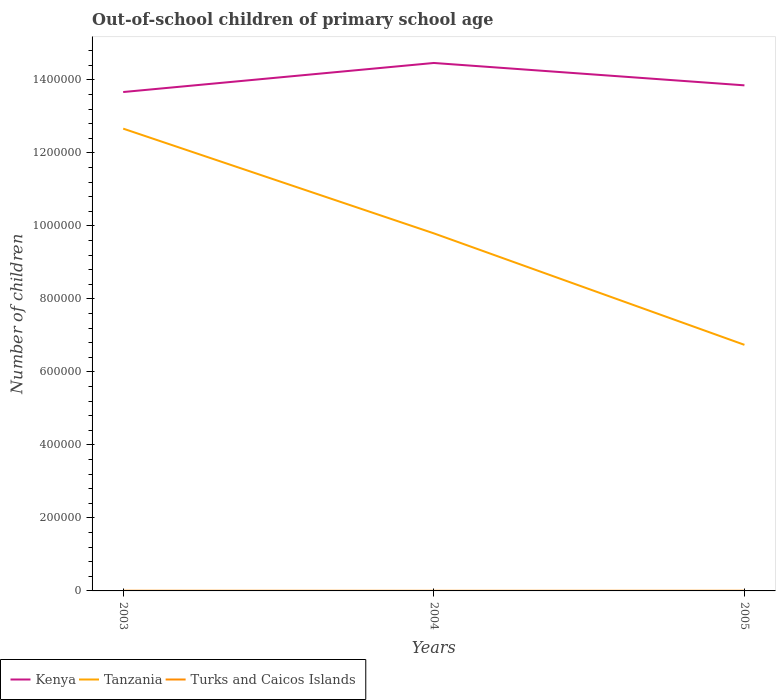How many different coloured lines are there?
Your answer should be compact. 3. Across all years, what is the maximum number of out-of-school children in Kenya?
Your answer should be compact. 1.37e+06. In which year was the number of out-of-school children in Turks and Caicos Islands maximum?
Ensure brevity in your answer.  2004. What is the total number of out-of-school children in Kenya in the graph?
Offer a terse response. -7.96e+04. What is the difference between the highest and the second highest number of out-of-school children in Turks and Caicos Islands?
Offer a terse response. 179. What is the difference between the highest and the lowest number of out-of-school children in Kenya?
Offer a terse response. 1. Is the number of out-of-school children in Turks and Caicos Islands strictly greater than the number of out-of-school children in Kenya over the years?
Make the answer very short. Yes. How many years are there in the graph?
Your answer should be very brief. 3. What is the difference between two consecutive major ticks on the Y-axis?
Your answer should be very brief. 2.00e+05. Does the graph contain grids?
Provide a short and direct response. No. How many legend labels are there?
Offer a very short reply. 3. What is the title of the graph?
Your answer should be very brief. Out-of-school children of primary school age. Does "Zimbabwe" appear as one of the legend labels in the graph?
Your response must be concise. No. What is the label or title of the Y-axis?
Provide a succinct answer. Number of children. What is the Number of children of Kenya in 2003?
Offer a very short reply. 1.37e+06. What is the Number of children of Tanzania in 2003?
Make the answer very short. 1.27e+06. What is the Number of children of Turks and Caicos Islands in 2003?
Your answer should be compact. 532. What is the Number of children in Kenya in 2004?
Provide a short and direct response. 1.45e+06. What is the Number of children of Tanzania in 2004?
Keep it short and to the point. 9.80e+05. What is the Number of children in Turks and Caicos Islands in 2004?
Ensure brevity in your answer.  353. What is the Number of children of Kenya in 2005?
Give a very brief answer. 1.38e+06. What is the Number of children in Tanzania in 2005?
Your answer should be very brief. 6.74e+05. What is the Number of children of Turks and Caicos Islands in 2005?
Your response must be concise. 477. Across all years, what is the maximum Number of children in Kenya?
Keep it short and to the point. 1.45e+06. Across all years, what is the maximum Number of children in Tanzania?
Give a very brief answer. 1.27e+06. Across all years, what is the maximum Number of children of Turks and Caicos Islands?
Your response must be concise. 532. Across all years, what is the minimum Number of children of Kenya?
Offer a very short reply. 1.37e+06. Across all years, what is the minimum Number of children in Tanzania?
Your answer should be compact. 6.74e+05. Across all years, what is the minimum Number of children of Turks and Caicos Islands?
Your answer should be very brief. 353. What is the total Number of children in Kenya in the graph?
Your response must be concise. 4.20e+06. What is the total Number of children in Tanzania in the graph?
Your answer should be compact. 2.92e+06. What is the total Number of children of Turks and Caicos Islands in the graph?
Keep it short and to the point. 1362. What is the difference between the Number of children in Kenya in 2003 and that in 2004?
Keep it short and to the point. -7.96e+04. What is the difference between the Number of children in Tanzania in 2003 and that in 2004?
Offer a terse response. 2.87e+05. What is the difference between the Number of children in Turks and Caicos Islands in 2003 and that in 2004?
Offer a very short reply. 179. What is the difference between the Number of children in Kenya in 2003 and that in 2005?
Give a very brief answer. -1.83e+04. What is the difference between the Number of children in Tanzania in 2003 and that in 2005?
Ensure brevity in your answer.  5.92e+05. What is the difference between the Number of children in Kenya in 2004 and that in 2005?
Your answer should be very brief. 6.13e+04. What is the difference between the Number of children in Tanzania in 2004 and that in 2005?
Your answer should be compact. 3.05e+05. What is the difference between the Number of children in Turks and Caicos Islands in 2004 and that in 2005?
Your answer should be very brief. -124. What is the difference between the Number of children of Kenya in 2003 and the Number of children of Tanzania in 2004?
Your answer should be compact. 3.87e+05. What is the difference between the Number of children in Kenya in 2003 and the Number of children in Turks and Caicos Islands in 2004?
Give a very brief answer. 1.37e+06. What is the difference between the Number of children of Tanzania in 2003 and the Number of children of Turks and Caicos Islands in 2004?
Offer a terse response. 1.27e+06. What is the difference between the Number of children in Kenya in 2003 and the Number of children in Tanzania in 2005?
Ensure brevity in your answer.  6.92e+05. What is the difference between the Number of children of Kenya in 2003 and the Number of children of Turks and Caicos Islands in 2005?
Make the answer very short. 1.37e+06. What is the difference between the Number of children of Tanzania in 2003 and the Number of children of Turks and Caicos Islands in 2005?
Give a very brief answer. 1.27e+06. What is the difference between the Number of children in Kenya in 2004 and the Number of children in Tanzania in 2005?
Your answer should be compact. 7.72e+05. What is the difference between the Number of children in Kenya in 2004 and the Number of children in Turks and Caicos Islands in 2005?
Your answer should be very brief. 1.45e+06. What is the difference between the Number of children of Tanzania in 2004 and the Number of children of Turks and Caicos Islands in 2005?
Offer a very short reply. 9.79e+05. What is the average Number of children in Kenya per year?
Keep it short and to the point. 1.40e+06. What is the average Number of children of Tanzania per year?
Keep it short and to the point. 9.73e+05. What is the average Number of children of Turks and Caicos Islands per year?
Offer a terse response. 454. In the year 2003, what is the difference between the Number of children in Kenya and Number of children in Tanzania?
Keep it short and to the point. 1.00e+05. In the year 2003, what is the difference between the Number of children in Kenya and Number of children in Turks and Caicos Islands?
Make the answer very short. 1.37e+06. In the year 2003, what is the difference between the Number of children of Tanzania and Number of children of Turks and Caicos Islands?
Ensure brevity in your answer.  1.27e+06. In the year 2004, what is the difference between the Number of children of Kenya and Number of children of Tanzania?
Provide a succinct answer. 4.67e+05. In the year 2004, what is the difference between the Number of children in Kenya and Number of children in Turks and Caicos Islands?
Provide a short and direct response. 1.45e+06. In the year 2004, what is the difference between the Number of children in Tanzania and Number of children in Turks and Caicos Islands?
Make the answer very short. 9.79e+05. In the year 2005, what is the difference between the Number of children in Kenya and Number of children in Tanzania?
Your answer should be very brief. 7.11e+05. In the year 2005, what is the difference between the Number of children in Kenya and Number of children in Turks and Caicos Islands?
Give a very brief answer. 1.38e+06. In the year 2005, what is the difference between the Number of children of Tanzania and Number of children of Turks and Caicos Islands?
Offer a terse response. 6.74e+05. What is the ratio of the Number of children of Kenya in 2003 to that in 2004?
Offer a very short reply. 0.94. What is the ratio of the Number of children in Tanzania in 2003 to that in 2004?
Offer a terse response. 1.29. What is the ratio of the Number of children of Turks and Caicos Islands in 2003 to that in 2004?
Your answer should be compact. 1.51. What is the ratio of the Number of children in Kenya in 2003 to that in 2005?
Provide a short and direct response. 0.99. What is the ratio of the Number of children in Tanzania in 2003 to that in 2005?
Offer a very short reply. 1.88. What is the ratio of the Number of children in Turks and Caicos Islands in 2003 to that in 2005?
Your answer should be compact. 1.12. What is the ratio of the Number of children in Kenya in 2004 to that in 2005?
Give a very brief answer. 1.04. What is the ratio of the Number of children in Tanzania in 2004 to that in 2005?
Provide a succinct answer. 1.45. What is the ratio of the Number of children in Turks and Caicos Islands in 2004 to that in 2005?
Give a very brief answer. 0.74. What is the difference between the highest and the second highest Number of children in Kenya?
Offer a terse response. 6.13e+04. What is the difference between the highest and the second highest Number of children of Tanzania?
Ensure brevity in your answer.  2.87e+05. What is the difference between the highest and the lowest Number of children of Kenya?
Offer a terse response. 7.96e+04. What is the difference between the highest and the lowest Number of children in Tanzania?
Offer a terse response. 5.92e+05. What is the difference between the highest and the lowest Number of children of Turks and Caicos Islands?
Provide a short and direct response. 179. 